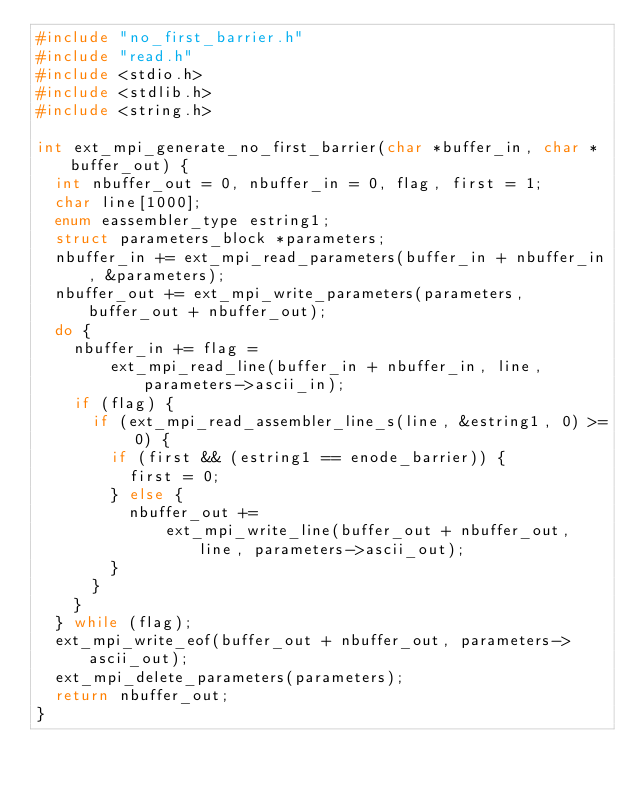<code> <loc_0><loc_0><loc_500><loc_500><_C_>#include "no_first_barrier.h"
#include "read.h"
#include <stdio.h>
#include <stdlib.h>
#include <string.h>

int ext_mpi_generate_no_first_barrier(char *buffer_in, char *buffer_out) {
  int nbuffer_out = 0, nbuffer_in = 0, flag, first = 1;
  char line[1000];
  enum eassembler_type estring1;
  struct parameters_block *parameters;
  nbuffer_in += ext_mpi_read_parameters(buffer_in + nbuffer_in, &parameters);
  nbuffer_out += ext_mpi_write_parameters(parameters, buffer_out + nbuffer_out);
  do {
    nbuffer_in += flag =
        ext_mpi_read_line(buffer_in + nbuffer_in, line, parameters->ascii_in);
    if (flag) {
      if (ext_mpi_read_assembler_line_s(line, &estring1, 0) >= 0) {
        if (first && (estring1 == enode_barrier)) {
          first = 0;
        } else {
          nbuffer_out +=
              ext_mpi_write_line(buffer_out + nbuffer_out, line, parameters->ascii_out);
        }
      }
    }
  } while (flag);
  ext_mpi_write_eof(buffer_out + nbuffer_out, parameters->ascii_out);
  ext_mpi_delete_parameters(parameters);
  return nbuffer_out;
}
</code> 